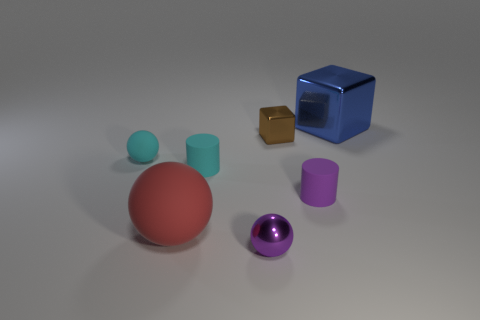How many other objects are there of the same material as the red object?
Provide a short and direct response. 3. Do the big object that is in front of the blue block and the tiny cyan cylinder have the same material?
Offer a terse response. Yes. What shape is the purple matte thing?
Offer a terse response. Cylinder. Are there more small things that are left of the purple metallic thing than blue shiny cubes?
Your answer should be very brief. Yes. There is a big metallic thing that is the same shape as the small brown shiny object; what is its color?
Offer a terse response. Blue. What is the shape of the small cyan rubber thing that is to the right of the red rubber thing?
Give a very brief answer. Cylinder. Are there any large blue cubes behind the purple metal sphere?
Provide a succinct answer. Yes. There is a large block that is made of the same material as the tiny brown object; what color is it?
Your answer should be very brief. Blue. There is a tiny sphere behind the tiny cyan cylinder; is it the same color as the ball in front of the large rubber thing?
Your response must be concise. No. What number of cubes are either small blue metal objects or tiny things?
Give a very brief answer. 1. 